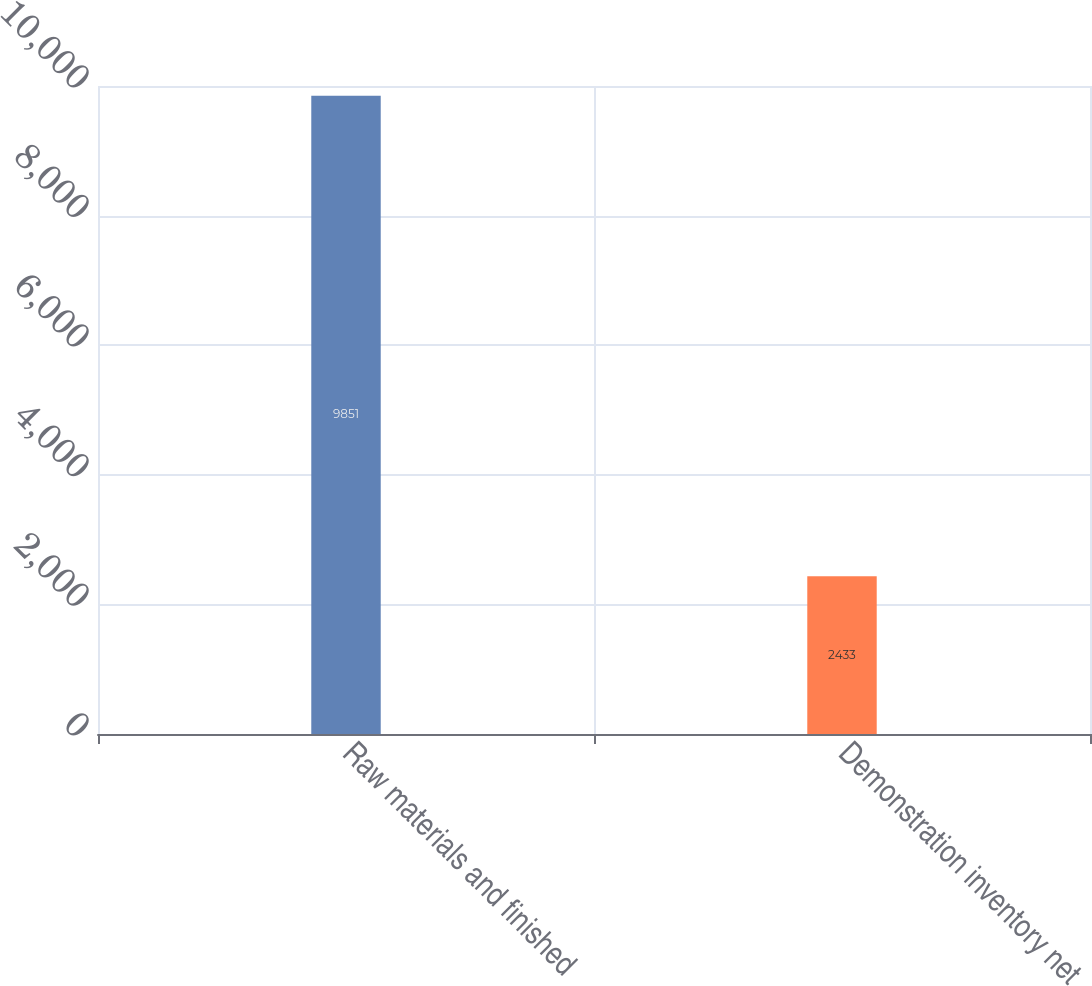<chart> <loc_0><loc_0><loc_500><loc_500><bar_chart><fcel>Raw materials and finished<fcel>Demonstration inventory net<nl><fcel>9851<fcel>2433<nl></chart> 